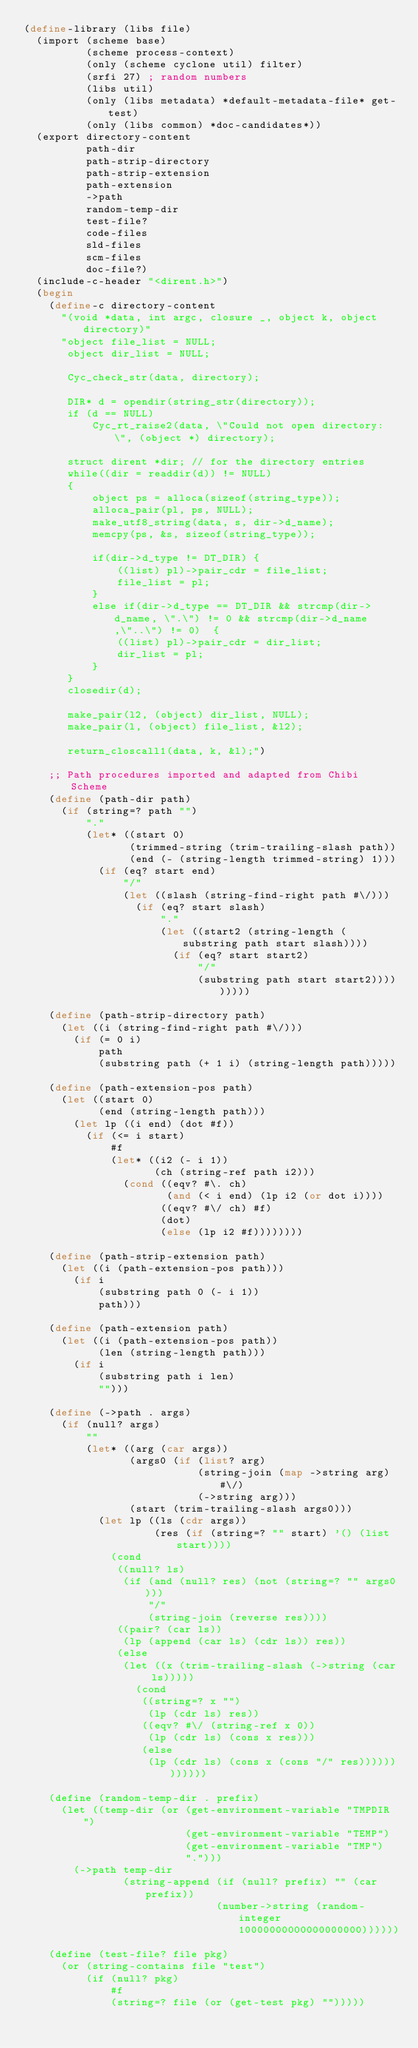Convert code to text. <code><loc_0><loc_0><loc_500><loc_500><_Scheme_>(define-library (libs file)
  (import (scheme base)
          (scheme process-context)
          (only (scheme cyclone util) filter)
          (srfi 27) ; random numbers
          (libs util)
          (only (libs metadata) *default-metadata-file* get-test)
          (only (libs common) *doc-candidates*))
  (export directory-content
          path-dir
          path-strip-directory
          path-strip-extension
          path-extension
          ->path
          random-temp-dir
          test-file?
          code-files
          sld-files
          scm-files
          doc-file?)
  (include-c-header "<dirent.h>")
  (begin
    (define-c directory-content
      "(void *data, int argc, closure _, object k, object directory)"
      "object file_list = NULL;
       object dir_list = NULL;
       
       Cyc_check_str(data, directory);
     
       DIR* d = opendir(string_str(directory));
       if (d == NULL)
           Cyc_rt_raise2(data, \"Could not open directory: \", (object *) directory);
    
       struct dirent *dir; // for the directory entries
       while((dir = readdir(d)) != NULL)
       {
           object ps = alloca(sizeof(string_type));
           alloca_pair(pl, ps, NULL);
           make_utf8_string(data, s, dir->d_name);
           memcpy(ps, &s, sizeof(string_type));
    
           if(dir->d_type != DT_DIR) {
               ((list) pl)->pair_cdr = file_list;
               file_list = pl;
           }
           else if(dir->d_type == DT_DIR && strcmp(dir->d_name, \".\") != 0 && strcmp(dir->d_name,\"..\") != 0)  {
               ((list) pl)->pair_cdr = dir_list;
               dir_list = pl;
           }
       }
       closedir(d);
    
       make_pair(l2, (object) dir_list, NULL);
       make_pair(l, (object) file_list, &l2);
    
       return_closcall1(data, k, &l);")

    ;; Path procedures imported and adapted from Chibi Scheme
    (define (path-dir path)
      (if (string=? path "")
          "."
          (let* ((start 0)
                 (trimmed-string (trim-trailing-slash path))
                 (end (- (string-length trimmed-string) 1)))
            (if (eq? start end)
                "/"
                (let ((slash (string-find-right path #\/)))
                  (if (eq? start slash)
                      "."
                      (let ((start2 (string-length (substring path start slash))))
                        (if (eq? start start2)
                            "/"
                            (substring path start start2)))))))))

    (define (path-strip-directory path)
      (let ((i (string-find-right path #\/)))
        (if (= 0 i)
            path
            (substring path (+ 1 i) (string-length path)))))

    (define (path-extension-pos path)
      (let ((start 0)
            (end (string-length path)))
        (let lp ((i end) (dot #f))
          (if (<= i start)
              #f
              (let* ((i2 (- i 1))
                     (ch (string-ref path i2)))
                (cond ((eqv? #\. ch)
                       (and (< i end) (lp i2 (or dot i))))
                      ((eqv? #\/ ch) #f)
                      (dot)
                      (else (lp i2 #f))))))))

    (define (path-strip-extension path)
      (let ((i (path-extension-pos path)))
        (if i
            (substring path 0 (- i 1))
            path)))

    (define (path-extension path)
      (let ((i (path-extension-pos path))
            (len (string-length path)))
        (if i
            (substring path i len)
            "")))

    (define (->path . args)
      (if (null? args)
          ""
          (let* ((arg (car args))
                 (args0 (if (list? arg)
                            (string-join (map ->string arg) #\/)
                            (->string arg)))
                 (start (trim-trailing-slash args0)))
            (let lp ((ls (cdr args))
                     (res (if (string=? "" start) '() (list start))))
              (cond
               ((null? ls)
                (if (and (null? res) (not (string=? "" args0)))
                    "/"
                    (string-join (reverse res))))
               ((pair? (car ls))
                (lp (append (car ls) (cdr ls)) res))
               (else
                (let ((x (trim-trailing-slash (->string (car ls)))))
                  (cond
                   ((string=? x "")
                    (lp (cdr ls) res))
                   ((eqv? #\/ (string-ref x 0))
                    (lp (cdr ls) (cons x res)))
                   (else
                    (lp (cdr ls) (cons x (cons "/" res))))))))))))

    (define (random-temp-dir . prefix)
      (let ((temp-dir (or (get-environment-variable "TMPDIR")
                          (get-environment-variable "TEMP")
                          (get-environment-variable "TMP")
                          ".")))
        (->path temp-dir
                (string-append (if (null? prefix) "" (car prefix))
                               (number->string (random-integer 10000000000000000000))))))

    (define (test-file? file pkg)
      (or (string-contains file "test")
          (if (null? pkg)
              #f
              (string=? file (or (get-test pkg) "")))))
</code> 